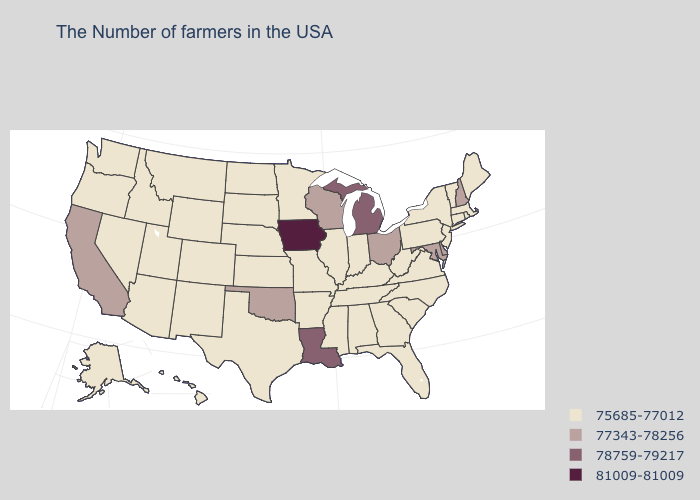What is the highest value in the Northeast ?
Be succinct. 77343-78256. Does the first symbol in the legend represent the smallest category?
Answer briefly. Yes. Is the legend a continuous bar?
Keep it brief. No. What is the lowest value in states that border North Dakota?
Answer briefly. 75685-77012. Does New York have a higher value than Maine?
Keep it brief. No. Name the states that have a value in the range 75685-77012?
Short answer required. Maine, Massachusetts, Rhode Island, Vermont, Connecticut, New York, New Jersey, Pennsylvania, Virginia, North Carolina, South Carolina, West Virginia, Florida, Georgia, Kentucky, Indiana, Alabama, Tennessee, Illinois, Mississippi, Missouri, Arkansas, Minnesota, Kansas, Nebraska, Texas, South Dakota, North Dakota, Wyoming, Colorado, New Mexico, Utah, Montana, Arizona, Idaho, Nevada, Washington, Oregon, Alaska, Hawaii. What is the value of Arkansas?
Answer briefly. 75685-77012. What is the highest value in the USA?
Keep it brief. 81009-81009. Does Michigan have the same value as Louisiana?
Keep it brief. Yes. What is the value of Illinois?
Quick response, please. 75685-77012. Among the states that border South Carolina , which have the highest value?
Keep it brief. North Carolina, Georgia. What is the lowest value in the MidWest?
Short answer required. 75685-77012. What is the highest value in states that border Arizona?
Give a very brief answer. 77343-78256. Which states have the lowest value in the South?
Give a very brief answer. Virginia, North Carolina, South Carolina, West Virginia, Florida, Georgia, Kentucky, Alabama, Tennessee, Mississippi, Arkansas, Texas. What is the highest value in states that border Washington?
Keep it brief. 75685-77012. 